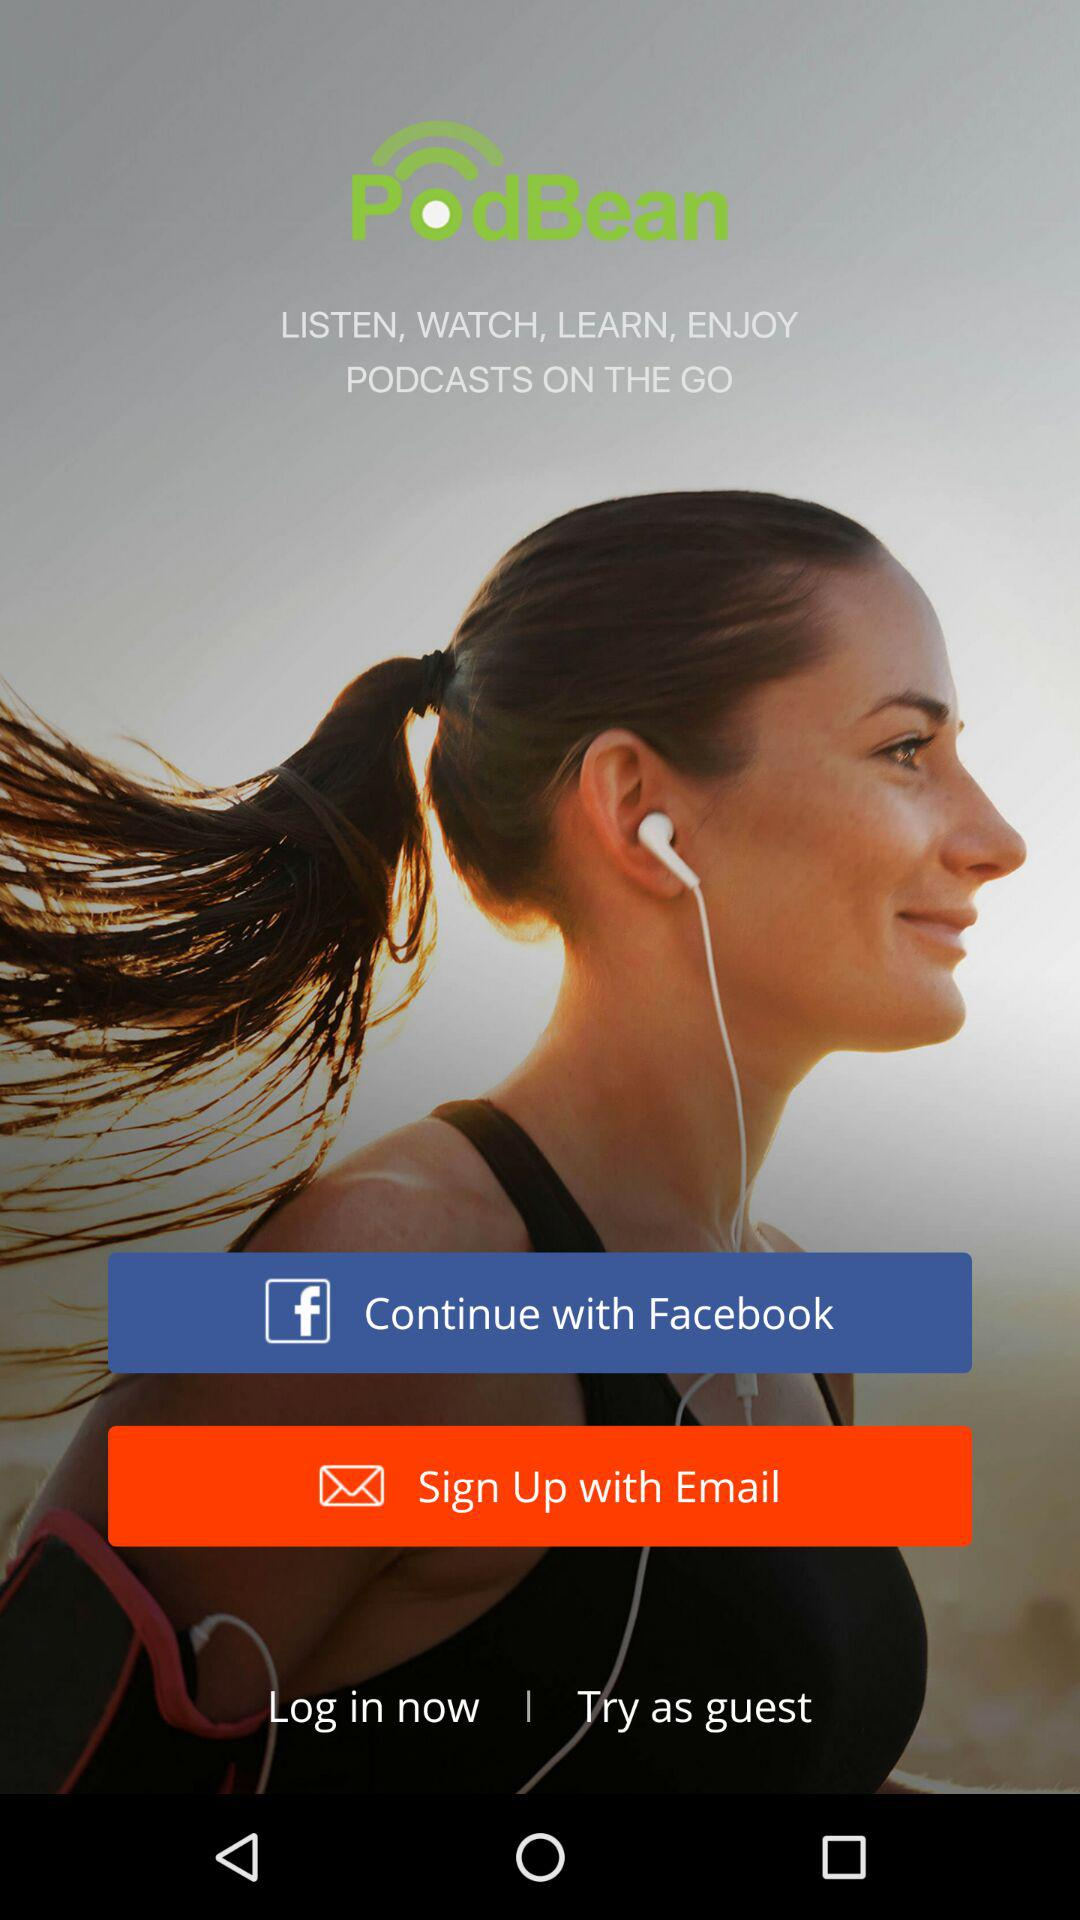What are the different app options to sign up with? The different app option to sign up with is "Facebook". 